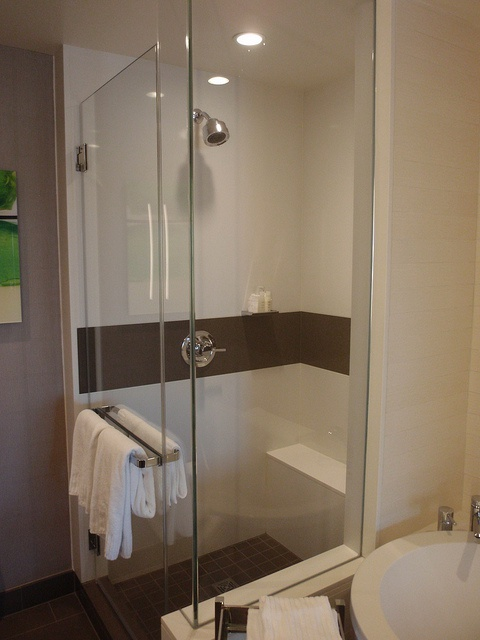Describe the objects in this image and their specific colors. I can see a sink in brown, darkgray, and gray tones in this image. 